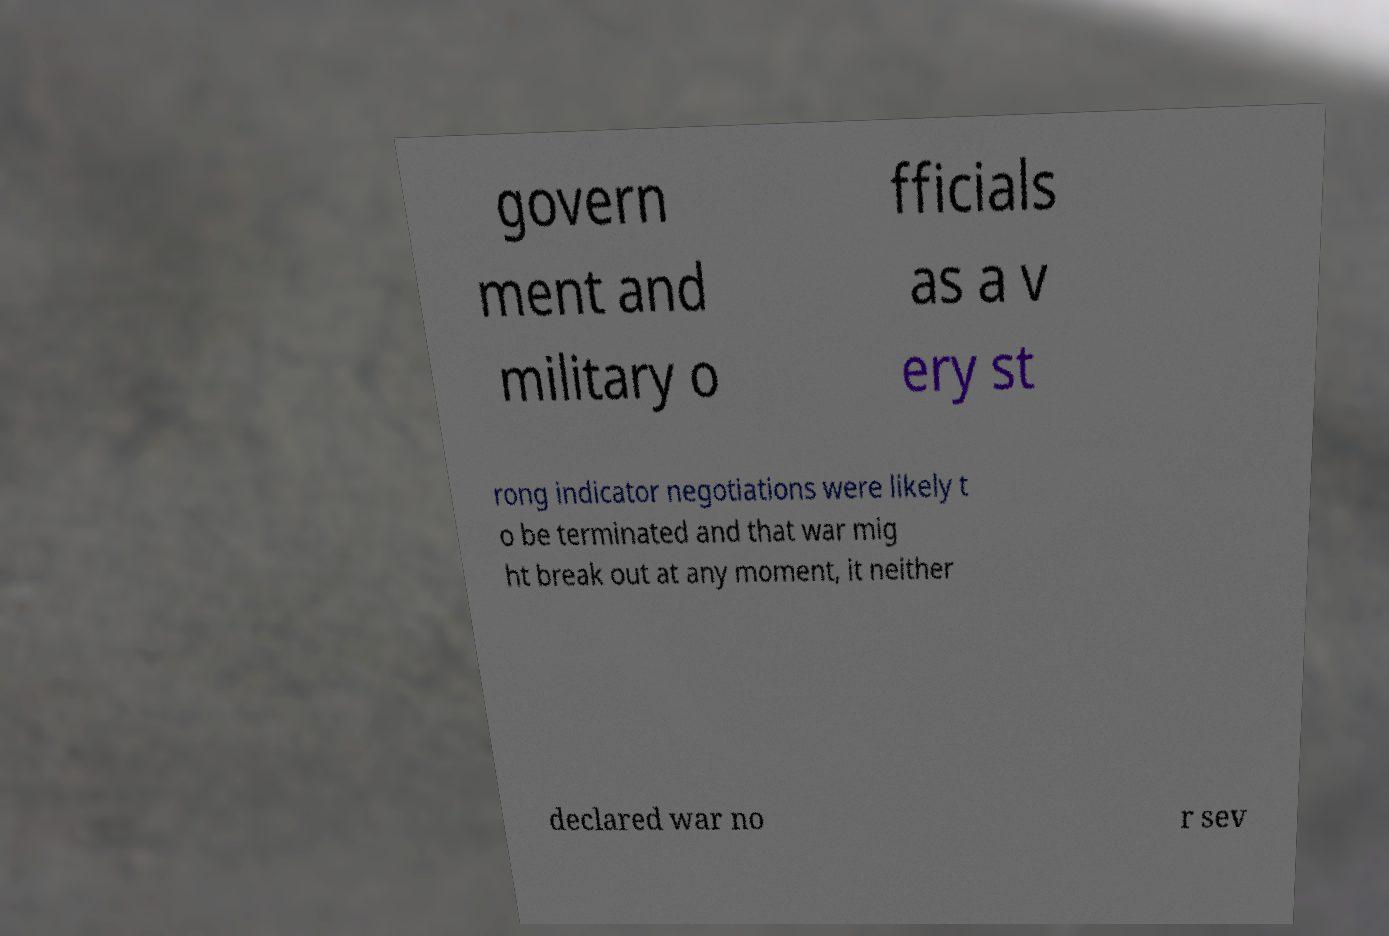There's text embedded in this image that I need extracted. Can you transcribe it verbatim? govern ment and military o fficials as a v ery st rong indicator negotiations were likely t o be terminated and that war mig ht break out at any moment, it neither declared war no r sev 